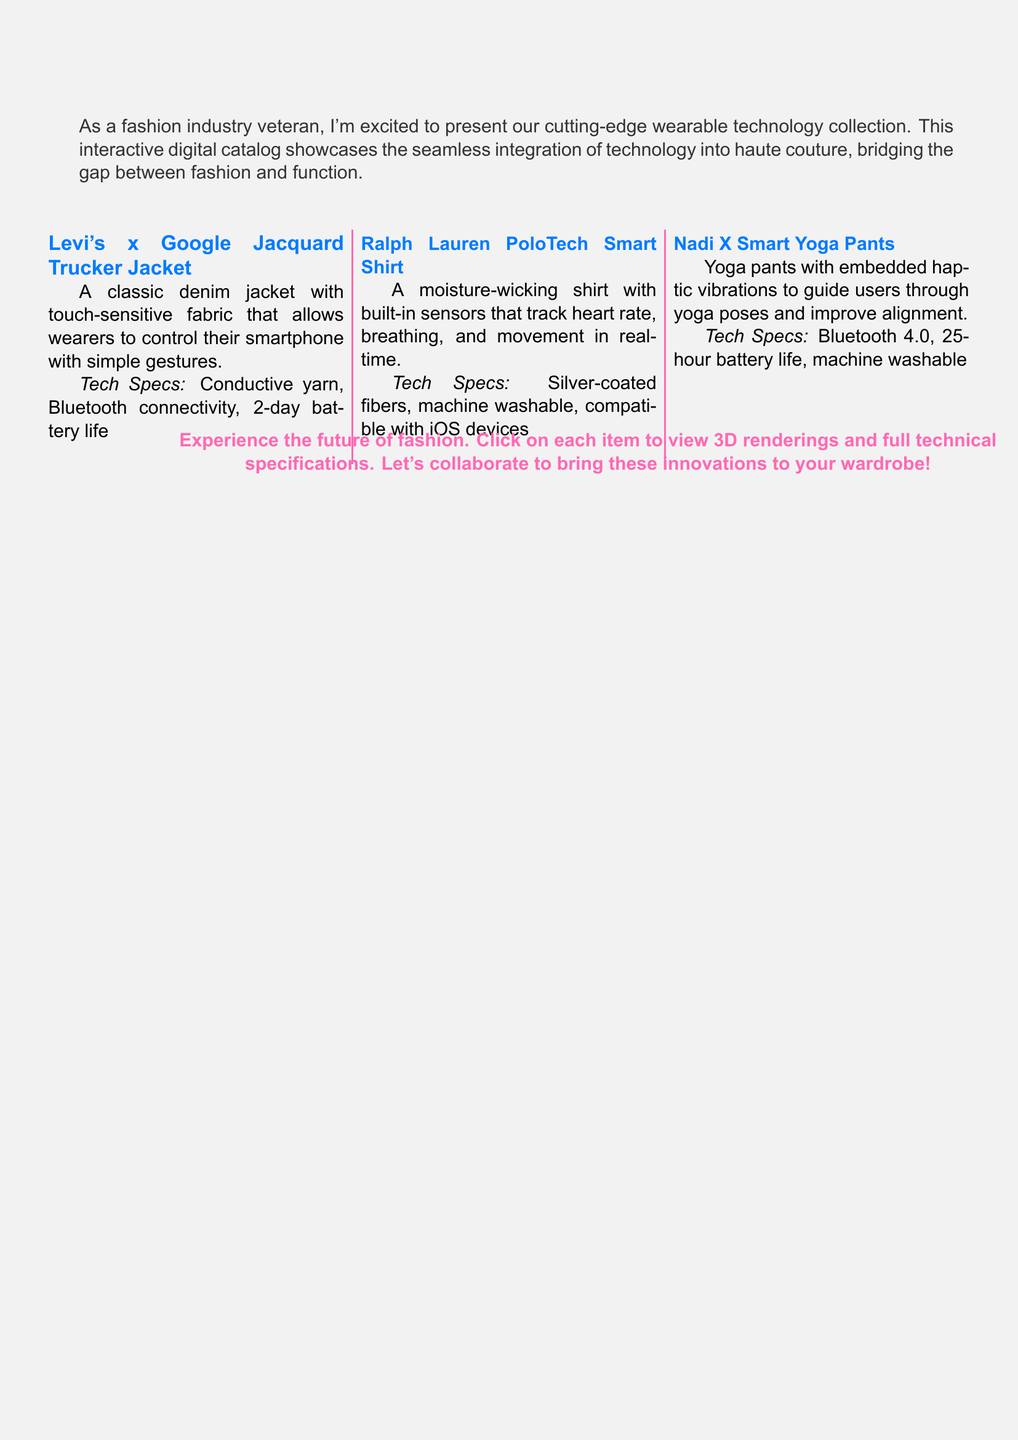What is the name of the first product? The first product mentioned in the catalog is the Levi's x Google Jacquard Trucker Jacket.
Answer: Levi's x Google Jacquard Trucker Jacket What feature does the Ralph Lauren PoloTech Smart Shirt track? The shirt tracks heart rate, breathing, and movement in real-time.
Answer: Heart rate, breathing, movement What type of fabric is used in the Levi's x Google Jacquard Trucker Jacket? The fabric used is touch-sensitive fabric that allows smartphone control.
Answer: Touch-sensitive fabric How long is the battery life of the Nadi X Smart Yoga Pants? The Nadi X Smart Yoga Pants have a battery life of 25 hours.
Answer: 25-hour battery life Which device compatibility is mentioned for the Ralph Lauren PoloTech Smart Shirt? The shirt is compatible with iOS devices.
Answer: iOS devices What color is used for the product titles in the catalog? The color used for the product titles is techblue.
Answer: Techblue How many products are showcased in the catalog? There are three products showcased in the catalog.
Answer: Three products What is the primary purpose of the interactive digital catalog? The primary purpose is to showcase wearable technology integrated into clothing.
Answer: Showcase wearable technology What type of questions does the end note encourage readers to engage with? The end note encourages readers to click on items for 3D renderings and full technical specifications.
Answer: 3D renderings and full technical specifications 